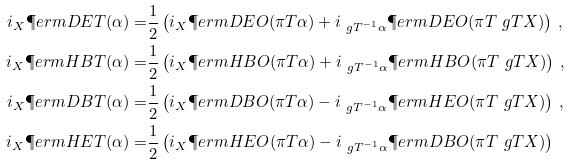<formula> <loc_0><loc_0><loc_500><loc_500>i _ { X } \P e r m D E T ( \alpha ) = & \frac { 1 } { 2 } \left ( i _ { X } \P e r m D E O ( \pi T \alpha ) + i _ { \ g T ^ { - 1 } \alpha } \P e r m D E O ( \pi T \ g T X ) \right ) \, , \\ i _ { X } \P e r m H B T ( \alpha ) = & \frac { 1 } { 2 } \left ( i _ { X } \P e r m H B O ( \pi T \alpha ) + i _ { \ g T ^ { - 1 } \alpha } \P e r m H B O ( \pi T \ g T X ) \right ) \, , \\ i _ { X } \P e r m D B T ( \alpha ) = & \frac { 1 } { 2 } \left ( i _ { X } \P e r m D B O ( \pi T \alpha ) - i _ { \ g T ^ { - 1 } \alpha } \P e r m H E O ( \pi T \ g T X ) \right ) \, , \\ i _ { X } \P e r m H E T ( \alpha ) = & \frac { 1 } { 2 } \left ( i _ { X } \P e r m H E O ( \pi T \alpha ) - i _ { \ g T ^ { - 1 } \alpha } \P e r m D B O ( \pi T \ g T X ) \right )</formula> 